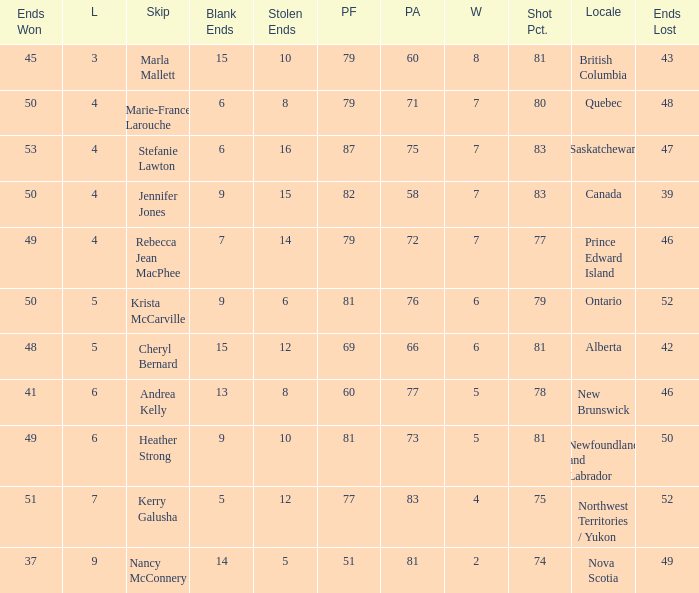What is the total of blank ends at Prince Edward Island? 7.0. 